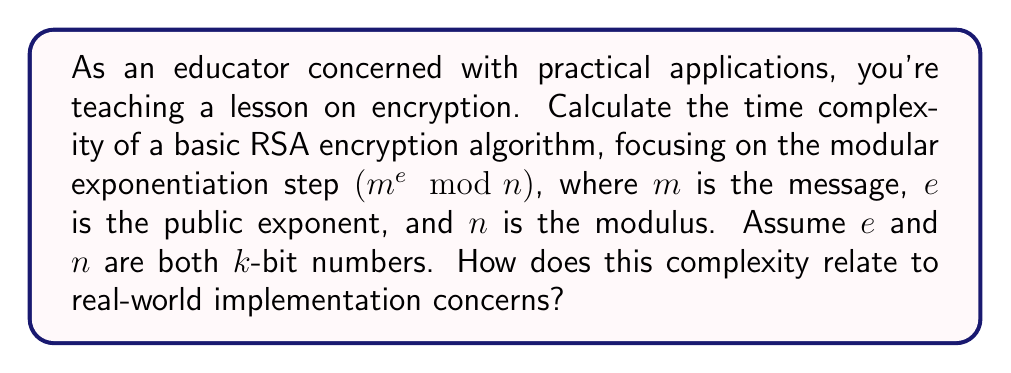What is the answer to this math problem? To calculate the time complexity of the basic RSA encryption algorithm, we focus on the modular exponentiation step, as it's the most computationally intensive part of the process.

1) The naive approach to calculate $m^e \mod n$ would require $e$ multiplications, resulting in $O(e)$ time complexity. However, $e$ can be very large (up to $k$ bits), making this approach impractical.

2) A more efficient method is the square-and-multiply algorithm (also known as binary exponentiation):

   - Convert $e$ to binary representation (at most $k$ bits)
   - For each bit of $e$ (from left to right):
     - Square the result
     - If the bit is 1, multiply by $m$

3) The number of operations in this algorithm is proportional to the number of bits in $e$, which is at most $k$.

4) Each multiplication or squaring operation is performed on $k$-bit numbers, which has a time complexity of $O(k^2)$ using the standard multiplication algorithm.

5) Therefore, the overall time complexity is $O(k \cdot k^2) = O(k^3)$.

In practice, more advanced algorithms like Karatsuba multiplication can reduce this to approximately $O(k^{2.58})$.

This cubic time complexity highlights why RSA is relatively slow for large key sizes, which are necessary for security. It explains the need for hybrid systems in real-world applications, where symmetric encryption is used for bulk data, and RSA is used only for key exchange.
Answer: $O(k^3)$, where $k$ is the number of bits in the modulus $n$. 